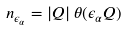Convert formula to latex. <formula><loc_0><loc_0><loc_500><loc_500>n _ { \epsilon _ { \alpha } } = | Q | \, \theta ( \epsilon _ { \alpha } Q )</formula> 